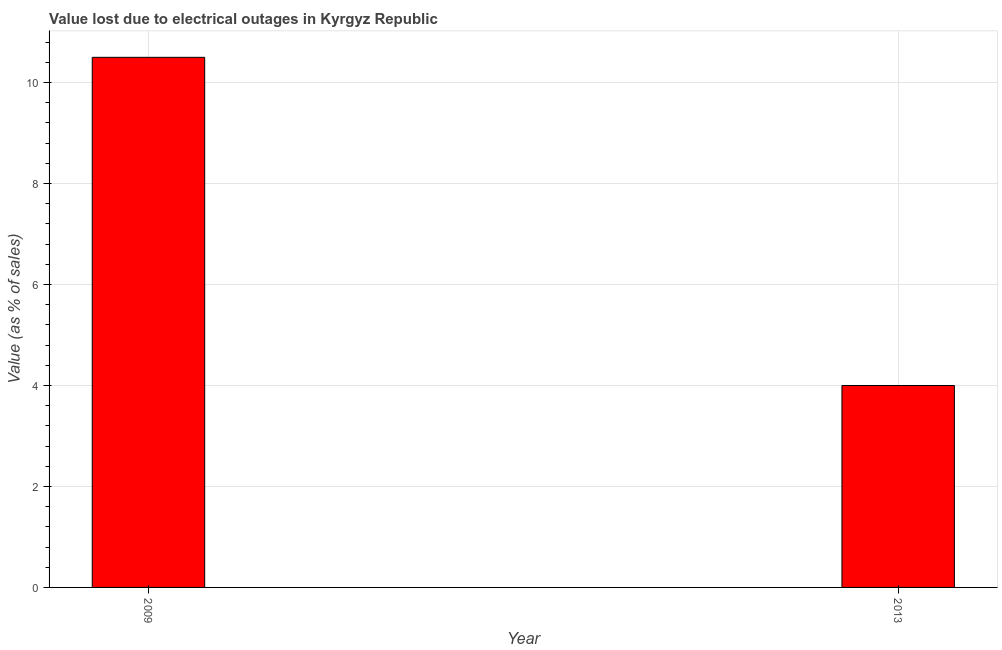What is the title of the graph?
Provide a succinct answer. Value lost due to electrical outages in Kyrgyz Republic. What is the label or title of the X-axis?
Your response must be concise. Year. What is the label or title of the Y-axis?
Your answer should be compact. Value (as % of sales). What is the value lost due to electrical outages in 2013?
Provide a short and direct response. 4. Across all years, what is the maximum value lost due to electrical outages?
Give a very brief answer. 10.5. Across all years, what is the minimum value lost due to electrical outages?
Ensure brevity in your answer.  4. In which year was the value lost due to electrical outages maximum?
Your answer should be compact. 2009. What is the sum of the value lost due to electrical outages?
Offer a very short reply. 14.5. What is the difference between the value lost due to electrical outages in 2009 and 2013?
Ensure brevity in your answer.  6.5. What is the average value lost due to electrical outages per year?
Offer a terse response. 7.25. What is the median value lost due to electrical outages?
Give a very brief answer. 7.25. Do a majority of the years between 2009 and 2013 (inclusive) have value lost due to electrical outages greater than 0.8 %?
Your answer should be very brief. Yes. What is the ratio of the value lost due to electrical outages in 2009 to that in 2013?
Give a very brief answer. 2.62. In how many years, is the value lost due to electrical outages greater than the average value lost due to electrical outages taken over all years?
Your response must be concise. 1. What is the Value (as % of sales) of 2009?
Give a very brief answer. 10.5. What is the ratio of the Value (as % of sales) in 2009 to that in 2013?
Provide a short and direct response. 2.62. 